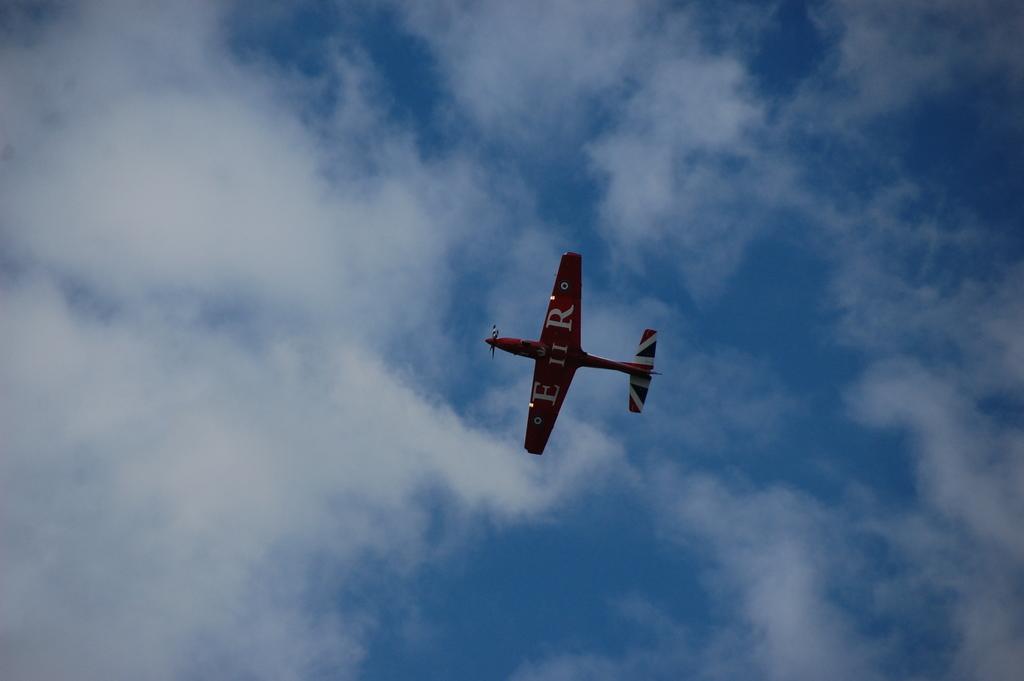Could you give a brief overview of what you see in this image? Here in this picture we can see an airplane flying in the air and we can see clouds in the sky. 